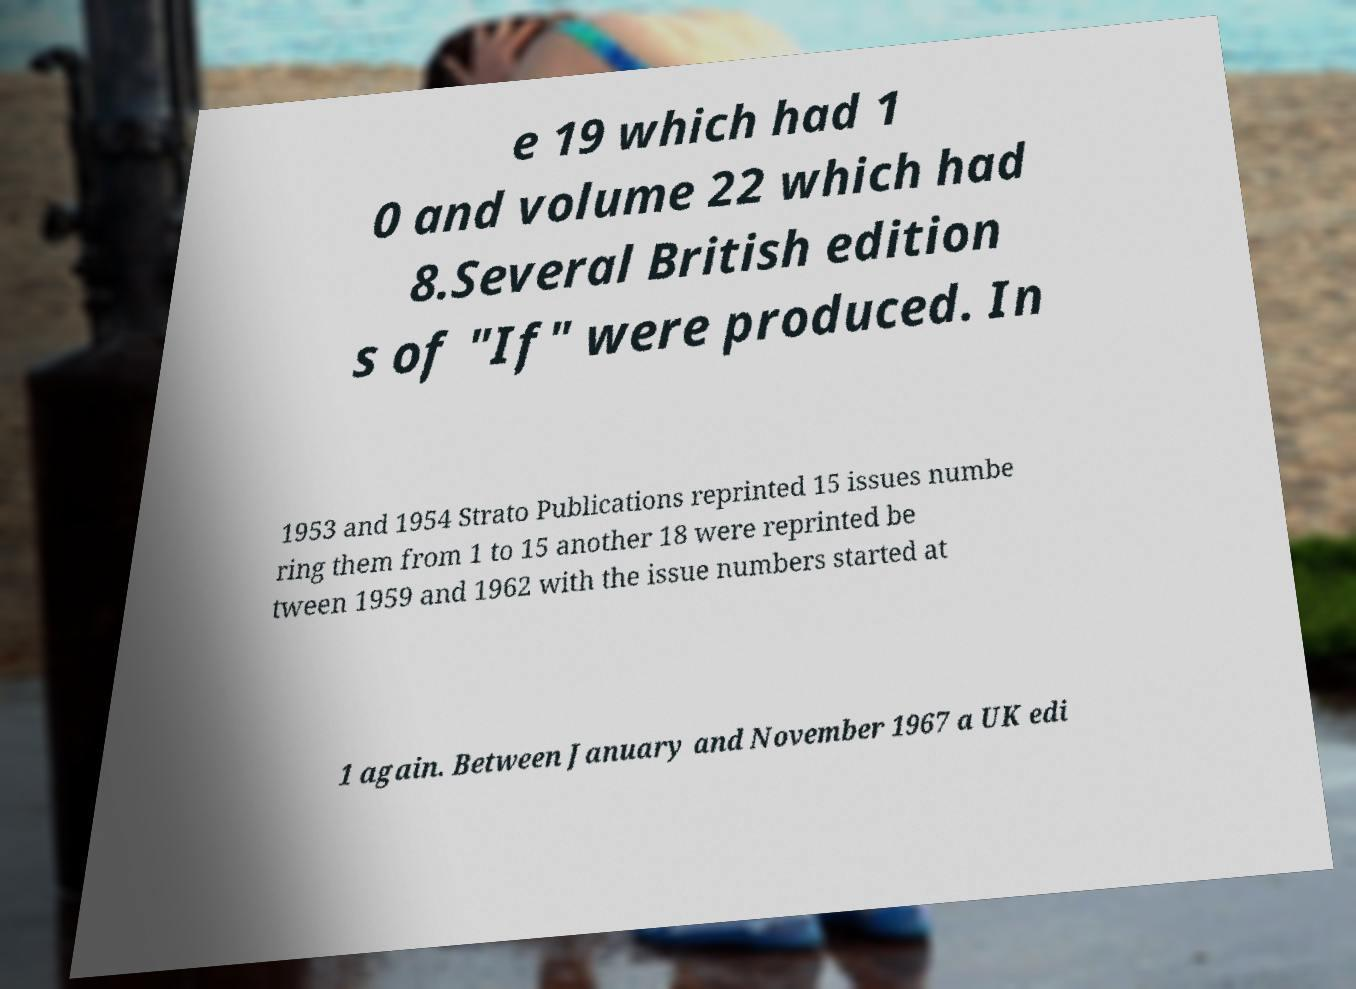There's text embedded in this image that I need extracted. Can you transcribe it verbatim? e 19 which had 1 0 and volume 22 which had 8.Several British edition s of "If" were produced. In 1953 and 1954 Strato Publications reprinted 15 issues numbe ring them from 1 to 15 another 18 were reprinted be tween 1959 and 1962 with the issue numbers started at 1 again. Between January and November 1967 a UK edi 